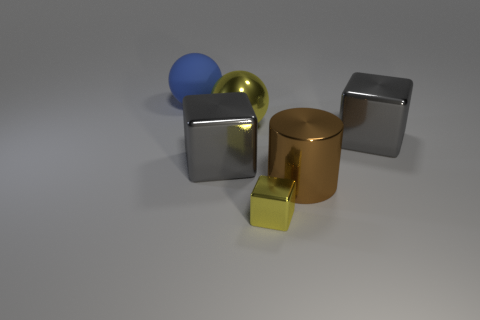What is the color of the metal thing that is the same shape as the blue rubber object? The metal object that shares its cylindrical shape with the blue rubber object is golden in color, exhibiting a shiny, reflective surface typical of polished metal. 